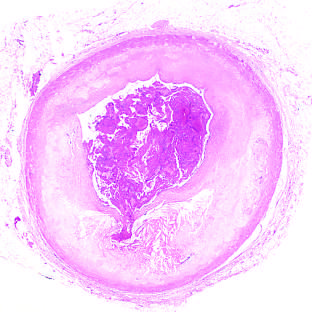what is superimposed on an atherosclerotic plaque with focal disruption of the fibrous cap, triggering fatal myocardial infarction?
Answer the question using a single word or phrase. Acute coronary throm-bosis 